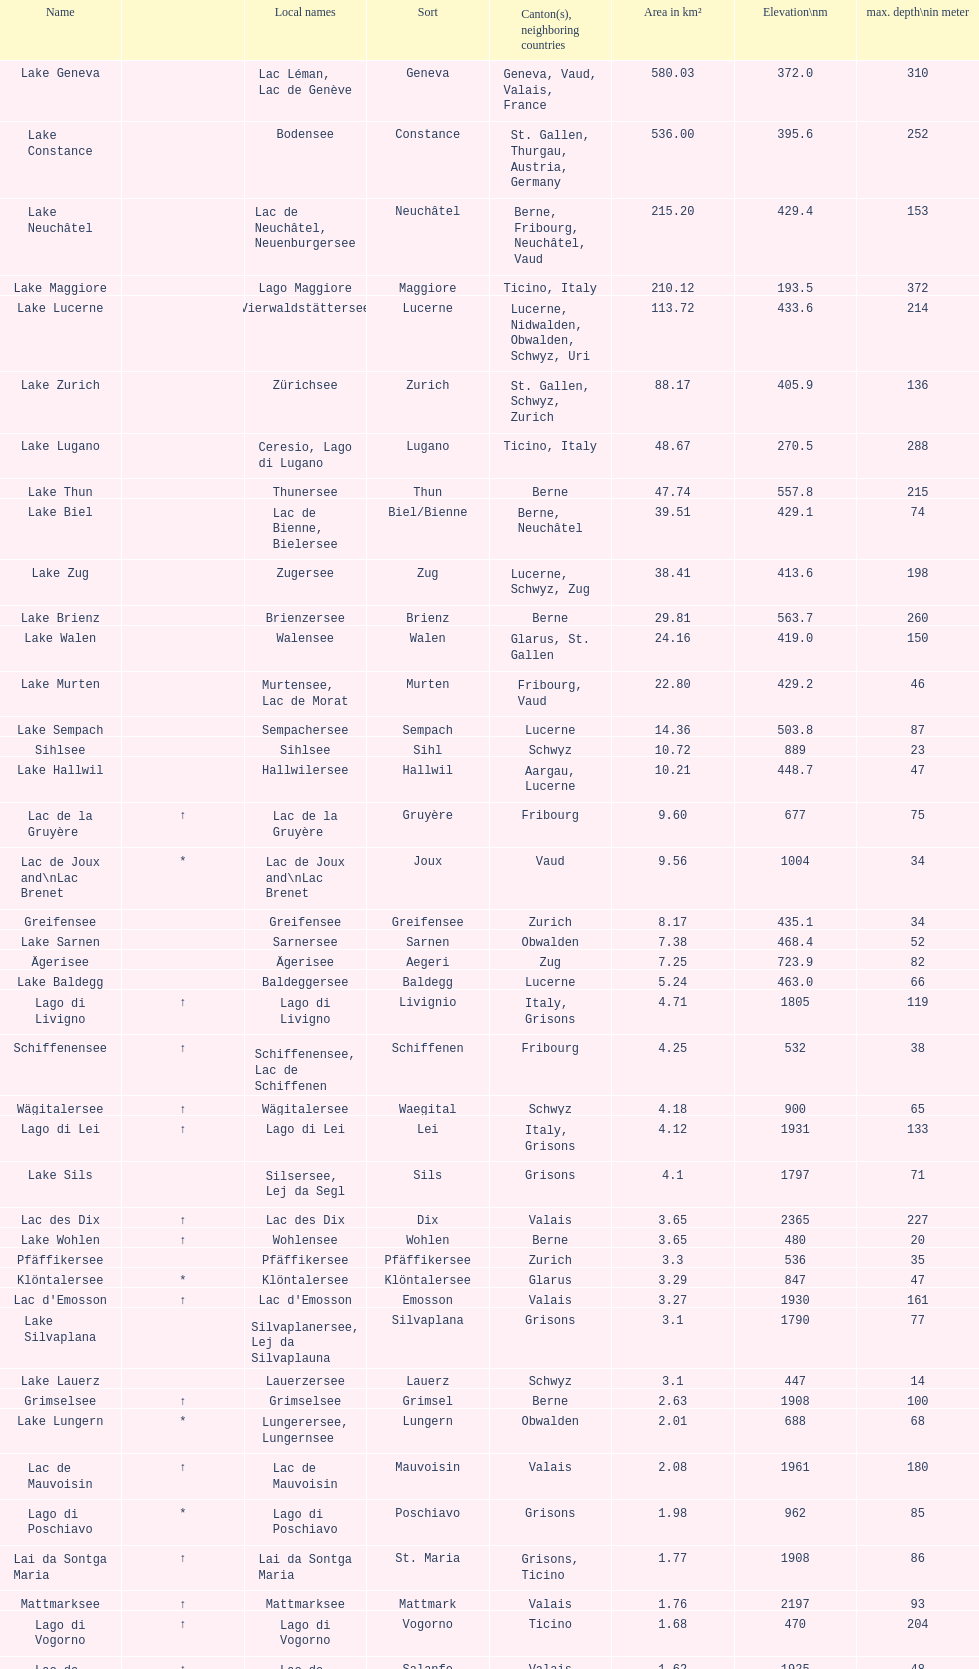What lake has the next highest elevation after lac des dix? Oberaarsee. 